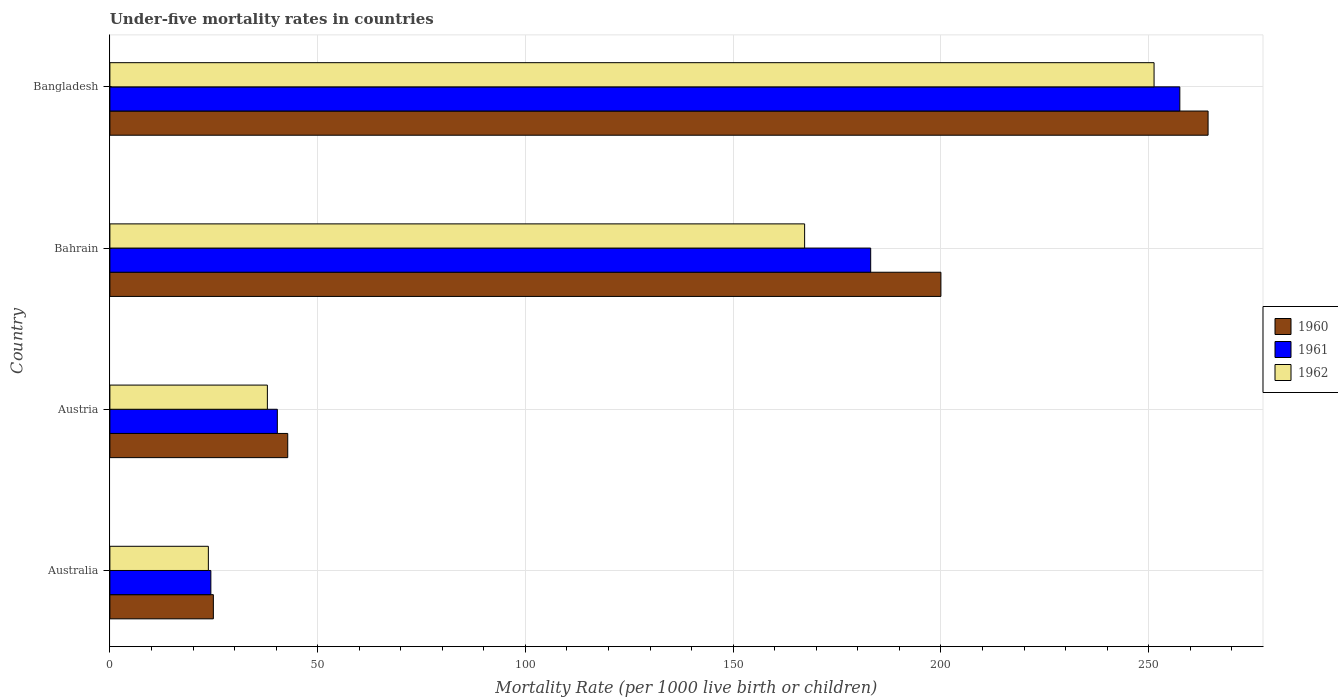Are the number of bars per tick equal to the number of legend labels?
Provide a short and direct response. Yes. What is the under-five mortality rate in 1962 in Austria?
Keep it short and to the point. 37.9. Across all countries, what is the maximum under-five mortality rate in 1962?
Make the answer very short. 251.3. Across all countries, what is the minimum under-five mortality rate in 1962?
Make the answer very short. 23.7. In which country was the under-five mortality rate in 1960 maximum?
Give a very brief answer. Bangladesh. What is the total under-five mortality rate in 1961 in the graph?
Offer a terse response. 505.2. What is the difference between the under-five mortality rate in 1960 in Austria and that in Bangladesh?
Provide a short and direct response. -221.5. What is the difference between the under-five mortality rate in 1961 in Bangladesh and the under-five mortality rate in 1962 in Austria?
Your answer should be very brief. 219.6. What is the average under-five mortality rate in 1961 per country?
Offer a terse response. 126.3. What is the difference between the under-five mortality rate in 1962 and under-five mortality rate in 1960 in Bangladesh?
Ensure brevity in your answer.  -13. In how many countries, is the under-five mortality rate in 1961 greater than 70 ?
Your response must be concise. 2. What is the ratio of the under-five mortality rate in 1960 in Australia to that in Bangladesh?
Your response must be concise. 0.09. Is the difference between the under-five mortality rate in 1962 in Austria and Bangladesh greater than the difference between the under-five mortality rate in 1960 in Austria and Bangladesh?
Your response must be concise. Yes. What is the difference between the highest and the second highest under-five mortality rate in 1960?
Provide a succinct answer. 64.3. What is the difference between the highest and the lowest under-five mortality rate in 1961?
Make the answer very short. 233.2. Is the sum of the under-five mortality rate in 1961 in Australia and Austria greater than the maximum under-five mortality rate in 1962 across all countries?
Your answer should be compact. No. What does the 1st bar from the top in Bangladesh represents?
Your answer should be compact. 1962. Is it the case that in every country, the sum of the under-five mortality rate in 1960 and under-five mortality rate in 1961 is greater than the under-five mortality rate in 1962?
Provide a succinct answer. Yes. Are all the bars in the graph horizontal?
Offer a very short reply. Yes. How many countries are there in the graph?
Offer a terse response. 4. Are the values on the major ticks of X-axis written in scientific E-notation?
Your answer should be compact. No. Does the graph contain grids?
Offer a terse response. Yes. How many legend labels are there?
Your answer should be very brief. 3. How are the legend labels stacked?
Give a very brief answer. Vertical. What is the title of the graph?
Your response must be concise. Under-five mortality rates in countries. Does "1965" appear as one of the legend labels in the graph?
Provide a succinct answer. No. What is the label or title of the X-axis?
Keep it short and to the point. Mortality Rate (per 1000 live birth or children). What is the label or title of the Y-axis?
Ensure brevity in your answer.  Country. What is the Mortality Rate (per 1000 live birth or children) of 1960 in Australia?
Your answer should be compact. 24.9. What is the Mortality Rate (per 1000 live birth or children) in 1961 in Australia?
Provide a succinct answer. 24.3. What is the Mortality Rate (per 1000 live birth or children) of 1962 in Australia?
Offer a terse response. 23.7. What is the Mortality Rate (per 1000 live birth or children) in 1960 in Austria?
Your response must be concise. 42.8. What is the Mortality Rate (per 1000 live birth or children) of 1961 in Austria?
Your response must be concise. 40.3. What is the Mortality Rate (per 1000 live birth or children) of 1962 in Austria?
Your response must be concise. 37.9. What is the Mortality Rate (per 1000 live birth or children) of 1961 in Bahrain?
Provide a short and direct response. 183.1. What is the Mortality Rate (per 1000 live birth or children) in 1962 in Bahrain?
Keep it short and to the point. 167.2. What is the Mortality Rate (per 1000 live birth or children) of 1960 in Bangladesh?
Your answer should be very brief. 264.3. What is the Mortality Rate (per 1000 live birth or children) in 1961 in Bangladesh?
Give a very brief answer. 257.5. What is the Mortality Rate (per 1000 live birth or children) of 1962 in Bangladesh?
Provide a short and direct response. 251.3. Across all countries, what is the maximum Mortality Rate (per 1000 live birth or children) in 1960?
Your answer should be compact. 264.3. Across all countries, what is the maximum Mortality Rate (per 1000 live birth or children) in 1961?
Offer a terse response. 257.5. Across all countries, what is the maximum Mortality Rate (per 1000 live birth or children) in 1962?
Provide a short and direct response. 251.3. Across all countries, what is the minimum Mortality Rate (per 1000 live birth or children) of 1960?
Your answer should be very brief. 24.9. Across all countries, what is the minimum Mortality Rate (per 1000 live birth or children) in 1961?
Make the answer very short. 24.3. Across all countries, what is the minimum Mortality Rate (per 1000 live birth or children) in 1962?
Offer a very short reply. 23.7. What is the total Mortality Rate (per 1000 live birth or children) of 1960 in the graph?
Provide a short and direct response. 532. What is the total Mortality Rate (per 1000 live birth or children) in 1961 in the graph?
Provide a short and direct response. 505.2. What is the total Mortality Rate (per 1000 live birth or children) in 1962 in the graph?
Keep it short and to the point. 480.1. What is the difference between the Mortality Rate (per 1000 live birth or children) in 1960 in Australia and that in Austria?
Give a very brief answer. -17.9. What is the difference between the Mortality Rate (per 1000 live birth or children) in 1961 in Australia and that in Austria?
Your response must be concise. -16. What is the difference between the Mortality Rate (per 1000 live birth or children) in 1962 in Australia and that in Austria?
Your answer should be very brief. -14.2. What is the difference between the Mortality Rate (per 1000 live birth or children) in 1960 in Australia and that in Bahrain?
Your response must be concise. -175.1. What is the difference between the Mortality Rate (per 1000 live birth or children) in 1961 in Australia and that in Bahrain?
Offer a terse response. -158.8. What is the difference between the Mortality Rate (per 1000 live birth or children) of 1962 in Australia and that in Bahrain?
Your answer should be very brief. -143.5. What is the difference between the Mortality Rate (per 1000 live birth or children) of 1960 in Australia and that in Bangladesh?
Offer a very short reply. -239.4. What is the difference between the Mortality Rate (per 1000 live birth or children) of 1961 in Australia and that in Bangladesh?
Offer a terse response. -233.2. What is the difference between the Mortality Rate (per 1000 live birth or children) of 1962 in Australia and that in Bangladesh?
Offer a very short reply. -227.6. What is the difference between the Mortality Rate (per 1000 live birth or children) of 1960 in Austria and that in Bahrain?
Offer a terse response. -157.2. What is the difference between the Mortality Rate (per 1000 live birth or children) of 1961 in Austria and that in Bahrain?
Make the answer very short. -142.8. What is the difference between the Mortality Rate (per 1000 live birth or children) in 1962 in Austria and that in Bahrain?
Provide a short and direct response. -129.3. What is the difference between the Mortality Rate (per 1000 live birth or children) in 1960 in Austria and that in Bangladesh?
Offer a terse response. -221.5. What is the difference between the Mortality Rate (per 1000 live birth or children) of 1961 in Austria and that in Bangladesh?
Make the answer very short. -217.2. What is the difference between the Mortality Rate (per 1000 live birth or children) of 1962 in Austria and that in Bangladesh?
Your answer should be compact. -213.4. What is the difference between the Mortality Rate (per 1000 live birth or children) of 1960 in Bahrain and that in Bangladesh?
Provide a succinct answer. -64.3. What is the difference between the Mortality Rate (per 1000 live birth or children) in 1961 in Bahrain and that in Bangladesh?
Provide a succinct answer. -74.4. What is the difference between the Mortality Rate (per 1000 live birth or children) in 1962 in Bahrain and that in Bangladesh?
Your response must be concise. -84.1. What is the difference between the Mortality Rate (per 1000 live birth or children) in 1960 in Australia and the Mortality Rate (per 1000 live birth or children) in 1961 in Austria?
Give a very brief answer. -15.4. What is the difference between the Mortality Rate (per 1000 live birth or children) in 1960 in Australia and the Mortality Rate (per 1000 live birth or children) in 1962 in Austria?
Make the answer very short. -13. What is the difference between the Mortality Rate (per 1000 live birth or children) in 1961 in Australia and the Mortality Rate (per 1000 live birth or children) in 1962 in Austria?
Your answer should be compact. -13.6. What is the difference between the Mortality Rate (per 1000 live birth or children) in 1960 in Australia and the Mortality Rate (per 1000 live birth or children) in 1961 in Bahrain?
Offer a very short reply. -158.2. What is the difference between the Mortality Rate (per 1000 live birth or children) in 1960 in Australia and the Mortality Rate (per 1000 live birth or children) in 1962 in Bahrain?
Your response must be concise. -142.3. What is the difference between the Mortality Rate (per 1000 live birth or children) in 1961 in Australia and the Mortality Rate (per 1000 live birth or children) in 1962 in Bahrain?
Offer a very short reply. -142.9. What is the difference between the Mortality Rate (per 1000 live birth or children) in 1960 in Australia and the Mortality Rate (per 1000 live birth or children) in 1961 in Bangladesh?
Provide a succinct answer. -232.6. What is the difference between the Mortality Rate (per 1000 live birth or children) of 1960 in Australia and the Mortality Rate (per 1000 live birth or children) of 1962 in Bangladesh?
Keep it short and to the point. -226.4. What is the difference between the Mortality Rate (per 1000 live birth or children) in 1961 in Australia and the Mortality Rate (per 1000 live birth or children) in 1962 in Bangladesh?
Offer a terse response. -227. What is the difference between the Mortality Rate (per 1000 live birth or children) in 1960 in Austria and the Mortality Rate (per 1000 live birth or children) in 1961 in Bahrain?
Offer a very short reply. -140.3. What is the difference between the Mortality Rate (per 1000 live birth or children) of 1960 in Austria and the Mortality Rate (per 1000 live birth or children) of 1962 in Bahrain?
Ensure brevity in your answer.  -124.4. What is the difference between the Mortality Rate (per 1000 live birth or children) in 1961 in Austria and the Mortality Rate (per 1000 live birth or children) in 1962 in Bahrain?
Provide a succinct answer. -126.9. What is the difference between the Mortality Rate (per 1000 live birth or children) in 1960 in Austria and the Mortality Rate (per 1000 live birth or children) in 1961 in Bangladesh?
Your response must be concise. -214.7. What is the difference between the Mortality Rate (per 1000 live birth or children) of 1960 in Austria and the Mortality Rate (per 1000 live birth or children) of 1962 in Bangladesh?
Offer a very short reply. -208.5. What is the difference between the Mortality Rate (per 1000 live birth or children) in 1961 in Austria and the Mortality Rate (per 1000 live birth or children) in 1962 in Bangladesh?
Offer a very short reply. -211. What is the difference between the Mortality Rate (per 1000 live birth or children) in 1960 in Bahrain and the Mortality Rate (per 1000 live birth or children) in 1961 in Bangladesh?
Ensure brevity in your answer.  -57.5. What is the difference between the Mortality Rate (per 1000 live birth or children) of 1960 in Bahrain and the Mortality Rate (per 1000 live birth or children) of 1962 in Bangladesh?
Your answer should be compact. -51.3. What is the difference between the Mortality Rate (per 1000 live birth or children) of 1961 in Bahrain and the Mortality Rate (per 1000 live birth or children) of 1962 in Bangladesh?
Offer a terse response. -68.2. What is the average Mortality Rate (per 1000 live birth or children) of 1960 per country?
Your answer should be compact. 133. What is the average Mortality Rate (per 1000 live birth or children) of 1961 per country?
Provide a succinct answer. 126.3. What is the average Mortality Rate (per 1000 live birth or children) of 1962 per country?
Make the answer very short. 120.03. What is the difference between the Mortality Rate (per 1000 live birth or children) of 1960 and Mortality Rate (per 1000 live birth or children) of 1962 in Australia?
Ensure brevity in your answer.  1.2. What is the difference between the Mortality Rate (per 1000 live birth or children) in 1961 and Mortality Rate (per 1000 live birth or children) in 1962 in Austria?
Your answer should be very brief. 2.4. What is the difference between the Mortality Rate (per 1000 live birth or children) in 1960 and Mortality Rate (per 1000 live birth or children) in 1961 in Bahrain?
Offer a terse response. 16.9. What is the difference between the Mortality Rate (per 1000 live birth or children) in 1960 and Mortality Rate (per 1000 live birth or children) in 1962 in Bahrain?
Offer a terse response. 32.8. What is the difference between the Mortality Rate (per 1000 live birth or children) of 1961 and Mortality Rate (per 1000 live birth or children) of 1962 in Bahrain?
Keep it short and to the point. 15.9. What is the ratio of the Mortality Rate (per 1000 live birth or children) of 1960 in Australia to that in Austria?
Offer a very short reply. 0.58. What is the ratio of the Mortality Rate (per 1000 live birth or children) in 1961 in Australia to that in Austria?
Your answer should be compact. 0.6. What is the ratio of the Mortality Rate (per 1000 live birth or children) of 1962 in Australia to that in Austria?
Ensure brevity in your answer.  0.63. What is the ratio of the Mortality Rate (per 1000 live birth or children) in 1960 in Australia to that in Bahrain?
Offer a terse response. 0.12. What is the ratio of the Mortality Rate (per 1000 live birth or children) of 1961 in Australia to that in Bahrain?
Offer a very short reply. 0.13. What is the ratio of the Mortality Rate (per 1000 live birth or children) of 1962 in Australia to that in Bahrain?
Ensure brevity in your answer.  0.14. What is the ratio of the Mortality Rate (per 1000 live birth or children) in 1960 in Australia to that in Bangladesh?
Provide a succinct answer. 0.09. What is the ratio of the Mortality Rate (per 1000 live birth or children) in 1961 in Australia to that in Bangladesh?
Ensure brevity in your answer.  0.09. What is the ratio of the Mortality Rate (per 1000 live birth or children) in 1962 in Australia to that in Bangladesh?
Your answer should be compact. 0.09. What is the ratio of the Mortality Rate (per 1000 live birth or children) in 1960 in Austria to that in Bahrain?
Your response must be concise. 0.21. What is the ratio of the Mortality Rate (per 1000 live birth or children) of 1961 in Austria to that in Bahrain?
Offer a terse response. 0.22. What is the ratio of the Mortality Rate (per 1000 live birth or children) in 1962 in Austria to that in Bahrain?
Offer a terse response. 0.23. What is the ratio of the Mortality Rate (per 1000 live birth or children) in 1960 in Austria to that in Bangladesh?
Make the answer very short. 0.16. What is the ratio of the Mortality Rate (per 1000 live birth or children) of 1961 in Austria to that in Bangladesh?
Give a very brief answer. 0.16. What is the ratio of the Mortality Rate (per 1000 live birth or children) in 1962 in Austria to that in Bangladesh?
Keep it short and to the point. 0.15. What is the ratio of the Mortality Rate (per 1000 live birth or children) of 1960 in Bahrain to that in Bangladesh?
Ensure brevity in your answer.  0.76. What is the ratio of the Mortality Rate (per 1000 live birth or children) in 1961 in Bahrain to that in Bangladesh?
Provide a succinct answer. 0.71. What is the ratio of the Mortality Rate (per 1000 live birth or children) in 1962 in Bahrain to that in Bangladesh?
Give a very brief answer. 0.67. What is the difference between the highest and the second highest Mortality Rate (per 1000 live birth or children) in 1960?
Give a very brief answer. 64.3. What is the difference between the highest and the second highest Mortality Rate (per 1000 live birth or children) of 1961?
Provide a short and direct response. 74.4. What is the difference between the highest and the second highest Mortality Rate (per 1000 live birth or children) of 1962?
Give a very brief answer. 84.1. What is the difference between the highest and the lowest Mortality Rate (per 1000 live birth or children) of 1960?
Give a very brief answer. 239.4. What is the difference between the highest and the lowest Mortality Rate (per 1000 live birth or children) in 1961?
Provide a succinct answer. 233.2. What is the difference between the highest and the lowest Mortality Rate (per 1000 live birth or children) in 1962?
Make the answer very short. 227.6. 